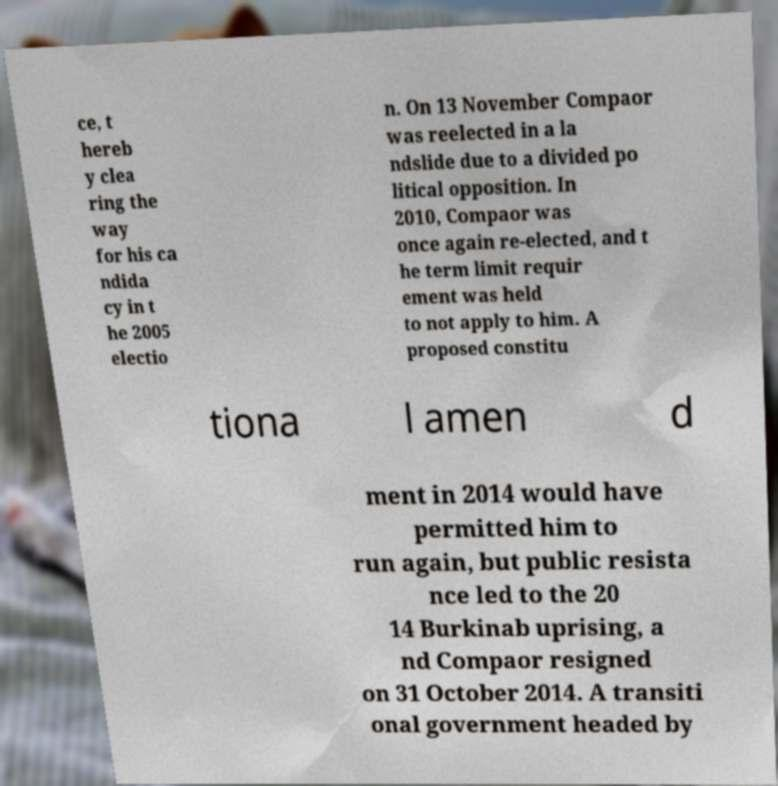Could you extract and type out the text from this image? ce, t hereb y clea ring the way for his ca ndida cy in t he 2005 electio n. On 13 November Compaor was reelected in a la ndslide due to a divided po litical opposition. In 2010, Compaor was once again re-elected, and t he term limit requir ement was held to not apply to him. A proposed constitu tiona l amen d ment in 2014 would have permitted him to run again, but public resista nce led to the 20 14 Burkinab uprising, a nd Compaor resigned on 31 October 2014. A transiti onal government headed by 